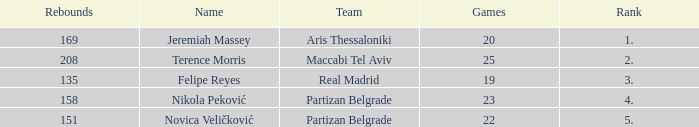What is the number of Games for Partizan Belgrade player Nikola Peković with a Rank of more than 4? None. 